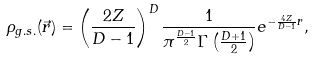<formula> <loc_0><loc_0><loc_500><loc_500>\rho _ { g . s . } ( \vec { r } ) = \left ( \frac { 2 Z } { D - 1 } \right ) ^ { D } \frac { 1 } { \pi ^ { \frac { D - 1 } { 2 } } \Gamma \left ( \frac { D + 1 } { 2 } \right ) } e ^ { - \frac { 4 Z } { D - 1 } r } ,</formula> 